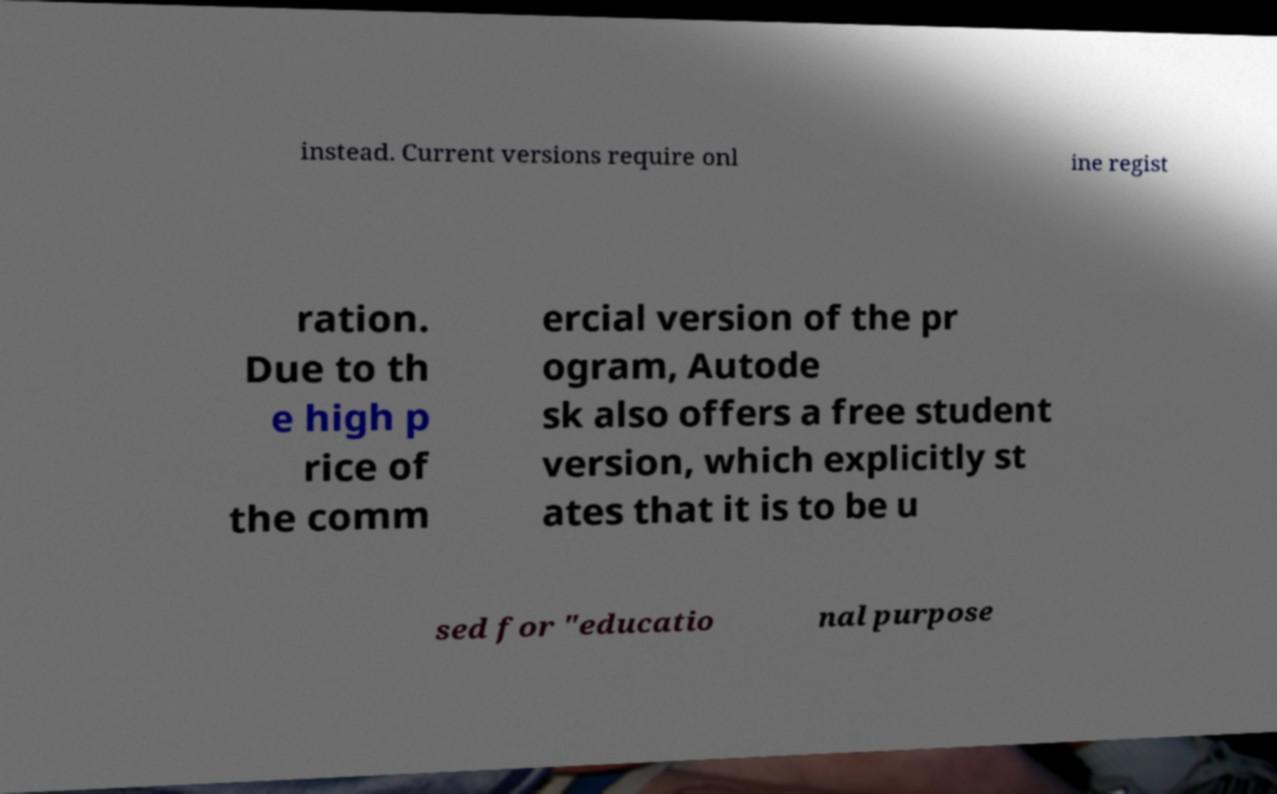What messages or text are displayed in this image? I need them in a readable, typed format. instead. Current versions require onl ine regist ration. Due to th e high p rice of the comm ercial version of the pr ogram, Autode sk also offers a free student version, which explicitly st ates that it is to be u sed for "educatio nal purpose 